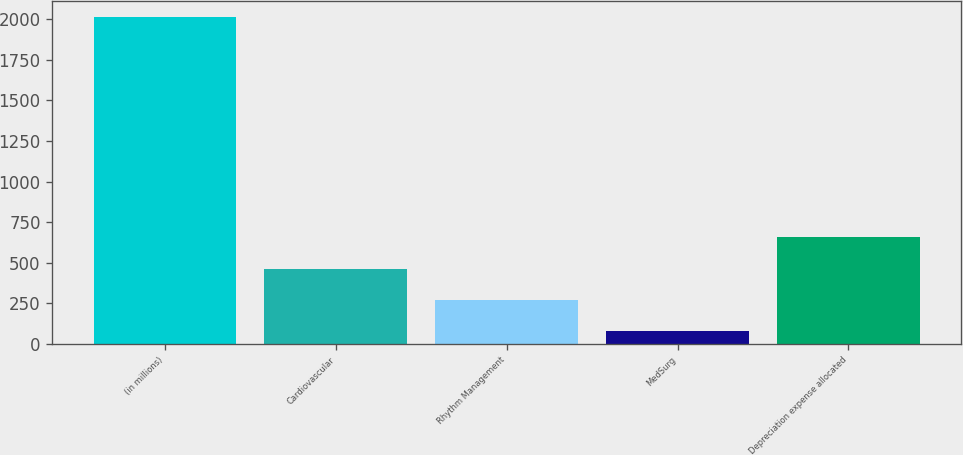<chart> <loc_0><loc_0><loc_500><loc_500><bar_chart><fcel>(in millions)<fcel>Cardiovascular<fcel>Rhythm Management<fcel>MedSurg<fcel>Depreciation expense allocated<nl><fcel>2014<fcel>462.8<fcel>268.9<fcel>75<fcel>656.7<nl></chart> 